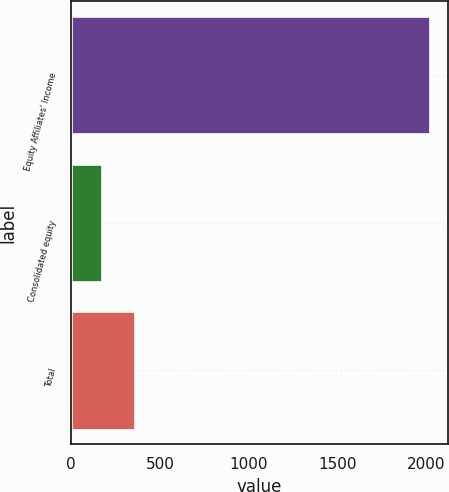Convert chart. <chart><loc_0><loc_0><loc_500><loc_500><bar_chart><fcel>Equity Affiliates' Income<fcel>Consolidated equity<fcel>Total<nl><fcel>2018<fcel>174.8<fcel>359.12<nl></chart> 